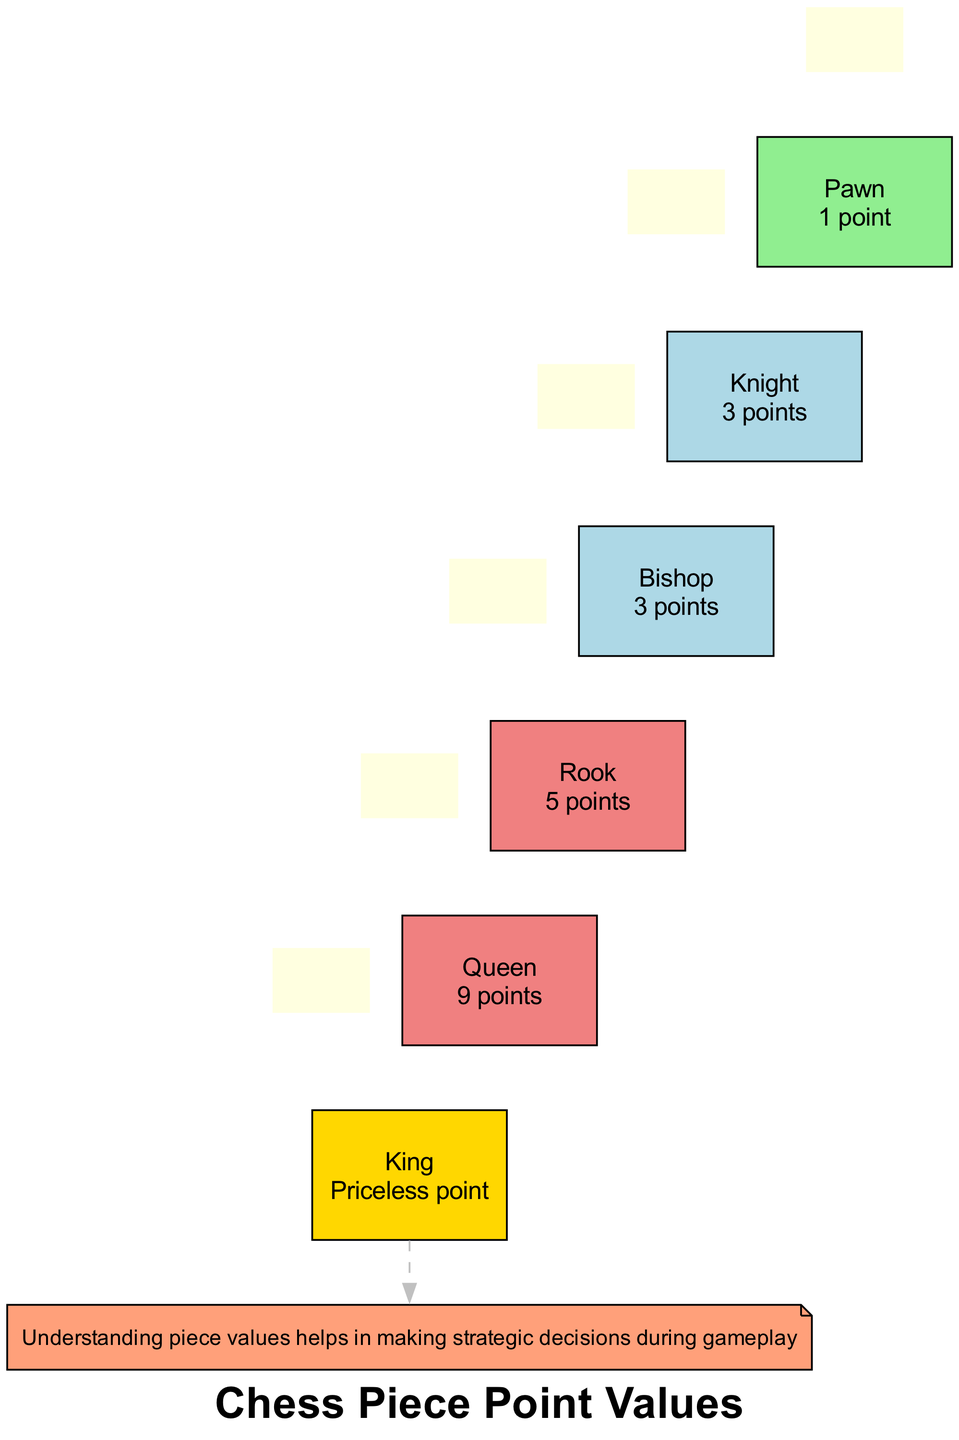What is the point value of a Knight? The diagram explicitly states that the Knight is assigned a point value of 3. You can find this information near the representation of the Knight.
Answer: 3 What color represents the Rook in the diagram? The Rook is colored lightcoral according to its point value. The diagram indicates that pieces valued at 5 points are represented in lightcoral, and Rook has a 5 point value.
Answer: lightcoral Which piece has a value of 'Priceless'? The diagram shows that the King is designated as 'Priceless'. You can locate this information beside the King’s representation on the diagram.
Answer: King How many pieces in total are represented in the diagram? Counting all the chess pieces listed in the diagram, there are six pieces: Pawn, Knight, Bishop, Rook, Queen, and King. This total can be easily derived from the list in the diagram.
Answer: 6 What is the point value of the Queen? The diagram specifically indicates that the Queen has a value of 9 points. This information appears directly alongside the representation of the Queen.
Answer: 9 Which piece has the same point value as the Bishop? The Bishop shares its point value of 3 with the Knight, as indicated in the diagram. Both pieces are marked with the same value, which allows for this conclusion.
Answer: Knight What color represents Pawn? According to the diagram, the Pawn is filled with lightgreen color. This is directly indicated in the section for the Pawn, which highlights the value assigned to it.
Answer: lightgreen What is the general note about understanding piece values? The note indicates that understanding piece values helps in making strategic decisions during gameplay, emphasizing the importance of this knowledge.
Answer: Understanding piece values helps in making strategic decisions during gameplay 